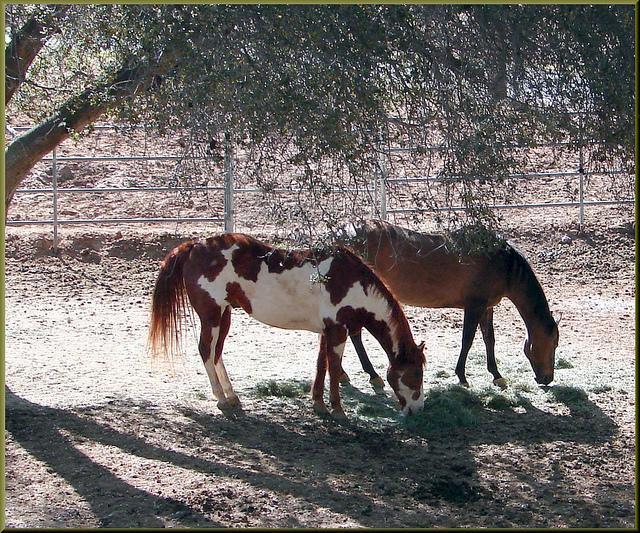How many horses are there?
Give a very brief answer. 2. 